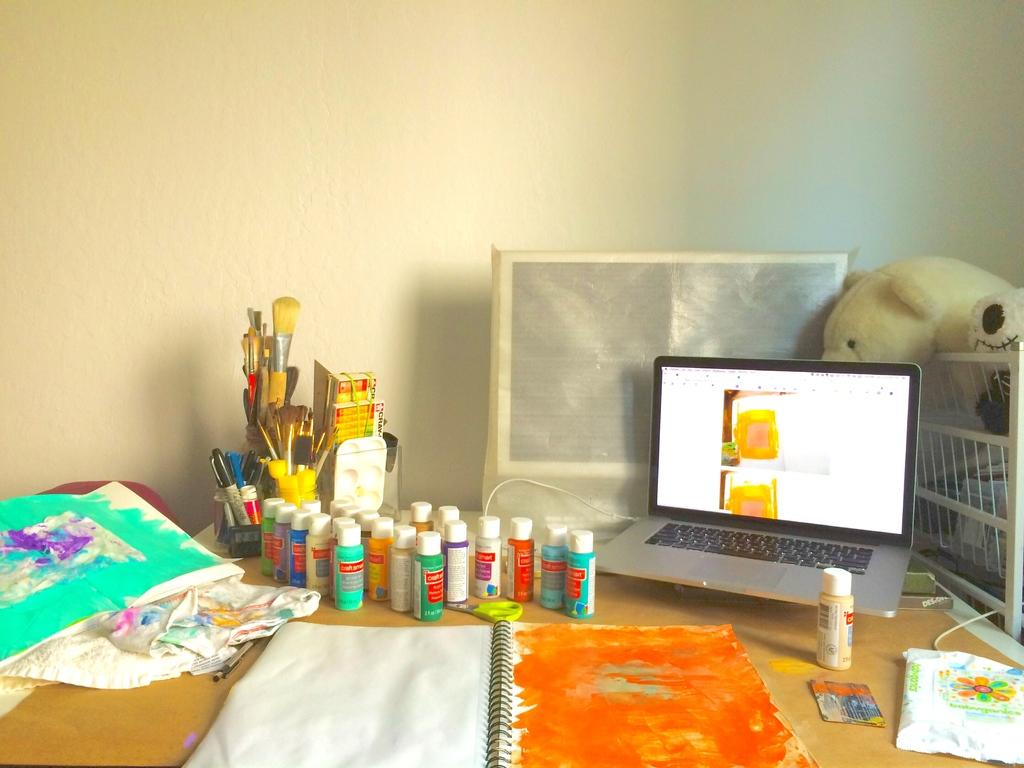What objects can be seen on the table in the image? There are color bottles, a laptop, a container with a teddy, unspecified things, painting paper, and a book with an orange cover on the table. Can you describe the laptop in the image? The laptop is on the table, but its specific features or brand cannot be determined from the image. What is the container holding on the table? The container is holding a teddy on the table. What type of paper is on the table? Painting paper is on the table. What is the color of the book's cover on the table? The book's cover is orange. What type of soda is being poured from the color bottles in the image? There is no indication that the color bottles contain soda, and the contents cannot be determined from the image. How does the air interact with the objects on the table in the image? The image does not provide information about the air's interaction with the objects on the table. Is there a pear on the table in the image? There is no mention of a pear in the provided facts, and it is not visible in the image. 